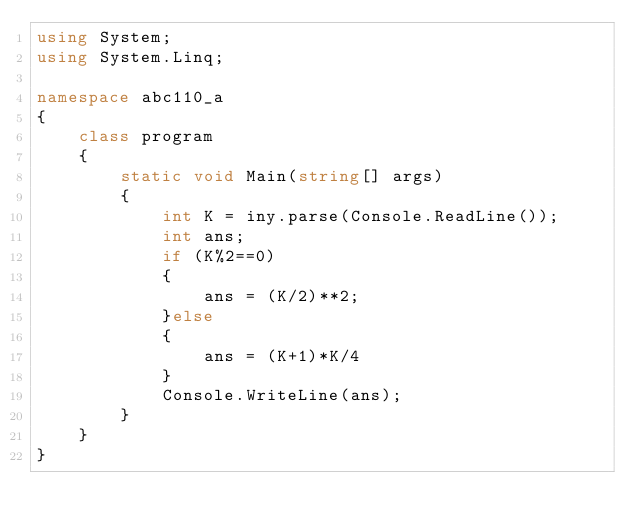Convert code to text. <code><loc_0><loc_0><loc_500><loc_500><_C#_>using System;
using System.Linq;
 
namespace abc110_a
{
    class program
    {
        static void Main(string[] args)
        {
            int K = iny.parse(Console.ReadLine());
            int ans;
            if (K%2==0)
            {
                ans = (K/2)**2;
            }else
            {
                ans = (K+1)*K/4
            }
            Console.WriteLine(ans);
        }
    }
}</code> 